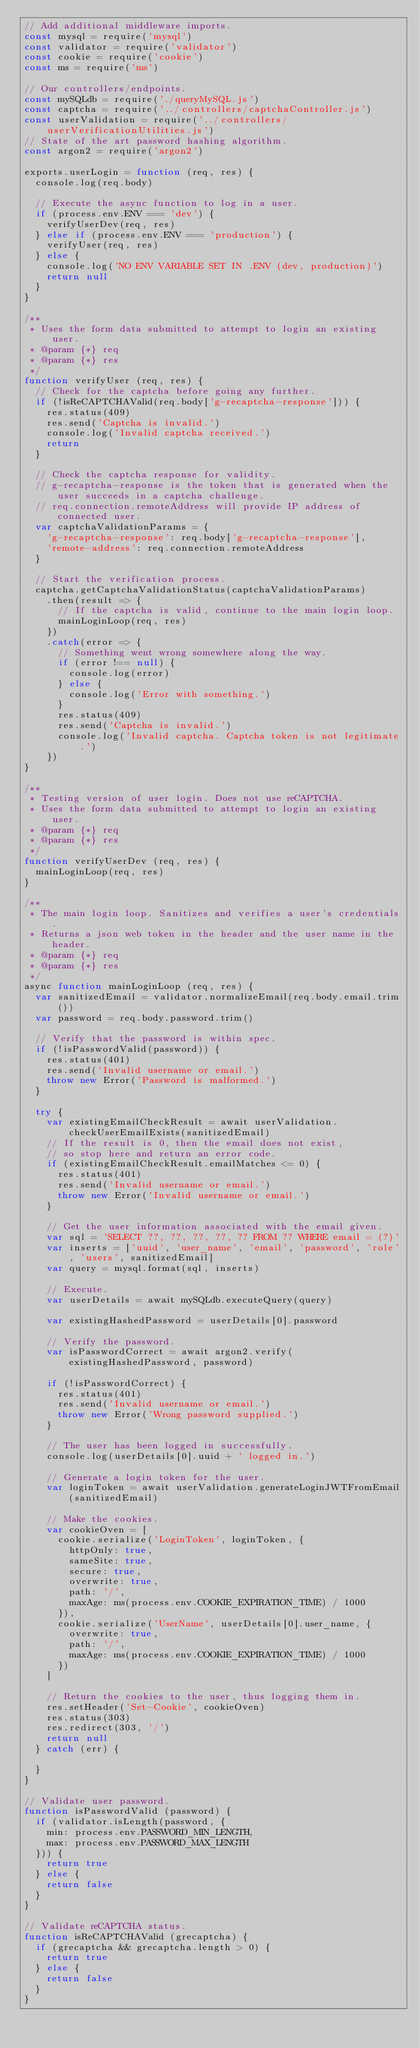Convert code to text. <code><loc_0><loc_0><loc_500><loc_500><_JavaScript_>// Add additional middleware imports.
const mysql = require('mysql')
const validator = require('validator')
const cookie = require('cookie')
const ms = require('ms')

// Our controllers/endpoints.
const mySQLdb = require('./queryMySQL.js')
const captcha = require('../controllers/captchaController.js')
const userValidation = require('../controllers/userVerificationUtilities.js')
// State of the art password hashing algorithm.
const argon2 = require('argon2')

exports.userLogin = function (req, res) {
  console.log(req.body)

  // Execute the async function to log in a user.
  if (process.env.ENV === 'dev') {
    verifyUserDev(req, res)
  } else if (process.env.ENV === 'production') {
    verifyUser(req, res)
  } else {
    console.log('NO ENV VARIABLE SET IN .ENV (dev, production)')
    return null
  }
}

/**
 * Uses the form data submitted to attempt to login an existing user.
 * @param {*} req
 * @param {*} res
 */
function verifyUser (req, res) {
  // Check for the captcha before going any further.
  if (!isReCAPTCHAValid(req.body['g-recaptcha-response'])) {
    res.status(409)
    res.send('Captcha is invalid.')
    console.log('Invalid captcha received.')
    return
  }

  // Check the captcha response for validity.
  // g-recaptcha-response is the token that is generated when the user succeeds in a captcha challenge.
  // req.connection.remoteAddress will provide IP address of connected user.
  var captchaValidationParams = {
    'g-recaptcha-response': req.body['g-recaptcha-response'],
    'remote-address': req.connection.remoteAddress
  }

  // Start the verification process.
  captcha.getCaptchaValidationStatus(captchaValidationParams)
    .then(result => {
      // If the captcha is valid, continue to the main login loop.
      mainLoginLoop(req, res)
    })
    .catch(error => {
      // Something went wrong somewhere along the way.
      if (error !== null) {
        console.log(error)
      } else {
        console.log('Error with something.')
      }
      res.status(409)
      res.send('Captcha is invalid.')
      console.log('Invalid captcha. Captcha token is not legitimate.')
    })
}

/**
 * Testing version of user login. Does not use reCAPTCHA.
 * Uses the form data submitted to attempt to login an existing user.
 * @param {*} req
 * @param {*} res
 */
function verifyUserDev (req, res) {
  mainLoginLoop(req, res)
}

/**
 * The main login loop. Sanitizes and verifies a user's credentials.
 * Returns a json web token in the header and the user name in the header.
 * @param {*} req
 * @param {*} res
 */
async function mainLoginLoop (req, res) {
  var sanitizedEmail = validator.normalizeEmail(req.body.email.trim())
  var password = req.body.password.trim()

  // Verify that the password is within spec.
  if (!isPasswordValid(password)) {
    res.status(401)
    res.send('Invalid username or email.')
    throw new Error('Password is malformed.')
  }

  try {
    var existingEmailCheckResult = await userValidation.checkUserEmailExists(sanitizedEmail)
    // If the result is 0, then the email does not exist,
    // so stop here and return an error code.
    if (existingEmailCheckResult.emailMatches <= 0) {
      res.status(401)
      res.send('Invalid username or email.')
      throw new Error('Invalid username or email.')
    }

    // Get the user information associated with the email given.
    var sql = 'SELECT ??, ??, ??, ??, ?? FROM ?? WHERE email = (?)'
    var inserts = ['uuid', 'user_name', 'email', 'password', 'role', 'users', sanitizedEmail]
    var query = mysql.format(sql, inserts)

    // Execute.
    var userDetails = await mySQLdb.executeQuery(query)

    var existingHashedPassword = userDetails[0].password

    // Verify the password.
    var isPasswordCorrect = await argon2.verify(existingHashedPassword, password)

    if (!isPasswordCorrect) {
      res.status(401)
      res.send('Invalid username or email.')
      throw new Error('Wrong password supplied.')
    }

    // The user has been logged in successfully.
    console.log(userDetails[0].uuid + ' logged in.')

    // Generate a login token for the user.
    var loginToken = await userValidation.generateLoginJWTFromEmail(sanitizedEmail)

    // Make the cookies.
    var cookieOven = [
      cookie.serialize('LoginToken', loginToken, {
        httpOnly: true,
        sameSite: true,
        secure: true,
        overwrite: true,
        path: '/',
        maxAge: ms(process.env.COOKIE_EXPIRATION_TIME) / 1000
      }),
      cookie.serialize('UserName', userDetails[0].user_name, {
        overwrite: true,
        path: '/',
        maxAge: ms(process.env.COOKIE_EXPIRATION_TIME) / 1000
      })
    ]

    // Return the cookies to the user, thus logging them in.
    res.setHeader('Set-Cookie', cookieOven)
    res.status(303)
    res.redirect(303, '/')
    return null
  } catch (err) {

  }
}

// Validate user password.
function isPasswordValid (password) {
  if (validator.isLength(password, {
    min: process.env.PASSWORD_MIN_LENGTH,
    max: process.env.PASSWORD_MAX_LENGTH
  })) {
    return true
  } else {
    return false
  }
}

// Validate reCAPTCHA status.
function isReCAPTCHAValid (grecaptcha) {
  if (grecaptcha && grecaptcha.length > 0) {
    return true
  } else {
    return false
  }
}
</code> 